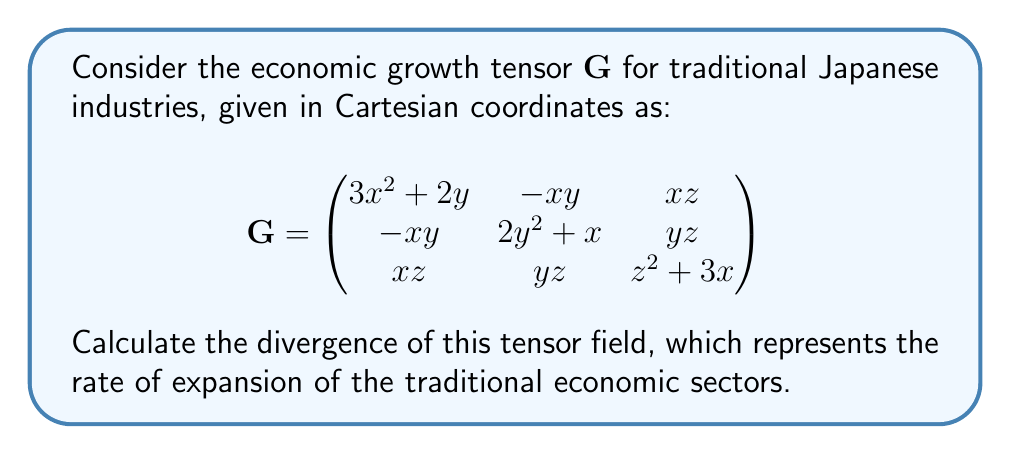Provide a solution to this math problem. To determine the divergence of the economic growth tensor $\mathbf{G}$, we need to calculate the trace of its gradient. The divergence in Cartesian coordinates is given by:

$$\text{div}(\mathbf{G}) = \nabla \cdot \mathbf{G} = \frac{\partial G_{xx}}{\partial x} + \frac{\partial G_{yy}}{\partial y} + \frac{\partial G_{zz}}{\partial z}$$

Let's calculate each term:

1. $\frac{\partial G_{xx}}{\partial x} = \frac{\partial}{\partial x}(3x^2 + 2y) = 6x$

2. $\frac{\partial G_{yy}}{\partial y} = \frac{\partial}{\partial y}(2y^2 + x) = 4y$

3. $\frac{\partial G_{zz}}{\partial z} = \frac{\partial}{\partial z}(z^2 + 3x) = 2z$

Now, we sum these terms:

$$\text{div}(\mathbf{G}) = 6x + 4y + 2z$$

This result represents the rate of expansion of traditional Japanese industries in the economic space defined by the tensor $\mathbf{G}$. A positive divergence indicates overall growth, which aligns with the conservative view of preserving and expanding traditional sectors.
Answer: $6x + 4y + 2z$ 